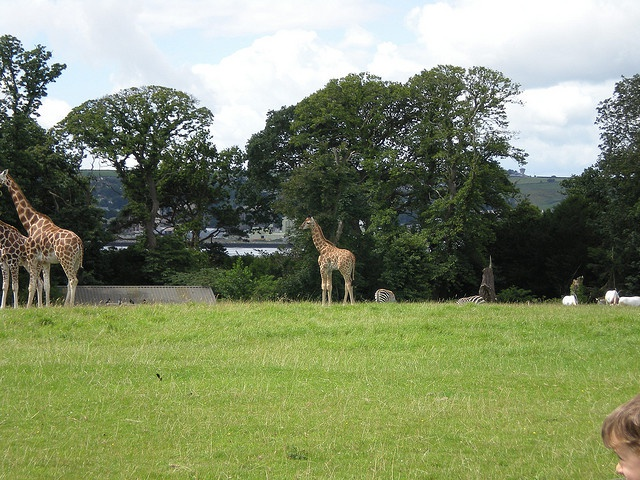Describe the objects in this image and their specific colors. I can see giraffe in white, gray, tan, and black tones, giraffe in white, tan, black, and gray tones, people in white, gray, tan, and maroon tones, giraffe in white, black, gray, and darkgray tones, and giraffe in white, gray, and darkgray tones in this image. 